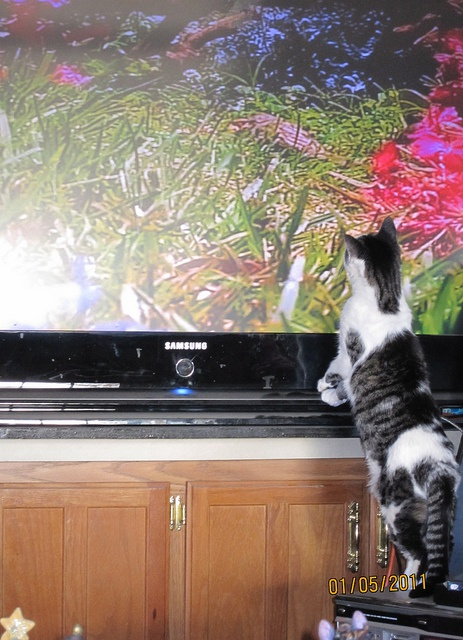Describe the objects in this image and their specific colors. I can see tv in gray, darkgray, black, and lightgray tones and cat in gray, black, lightgray, and darkgray tones in this image. 